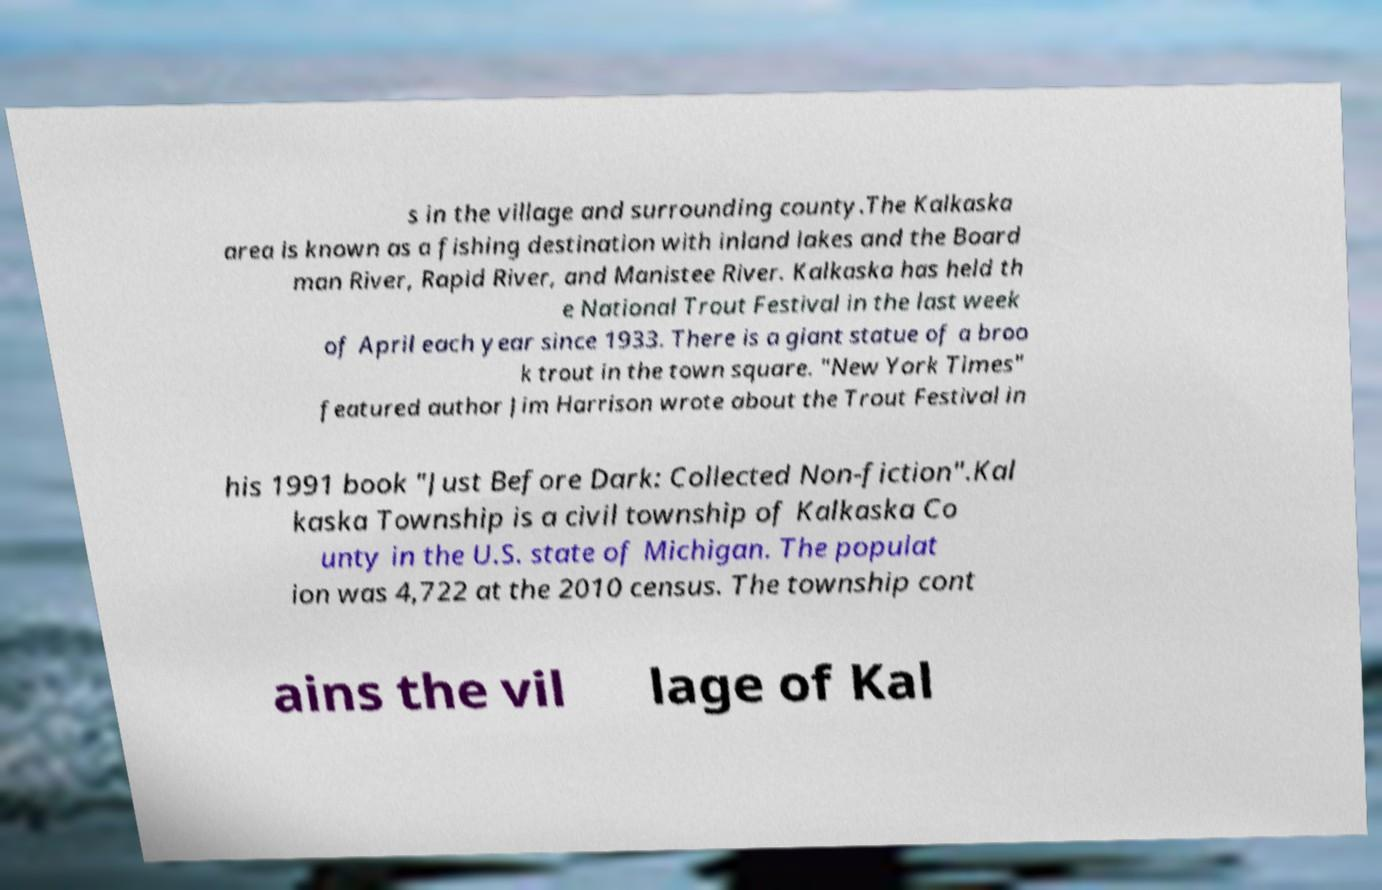Can you read and provide the text displayed in the image?This photo seems to have some interesting text. Can you extract and type it out for me? s in the village and surrounding county.The Kalkaska area is known as a fishing destination with inland lakes and the Board man River, Rapid River, and Manistee River. Kalkaska has held th e National Trout Festival in the last week of April each year since 1933. There is a giant statue of a broo k trout in the town square. "New York Times" featured author Jim Harrison wrote about the Trout Festival in his 1991 book "Just Before Dark: Collected Non-fiction".Kal kaska Township is a civil township of Kalkaska Co unty in the U.S. state of Michigan. The populat ion was 4,722 at the 2010 census. The township cont ains the vil lage of Kal 